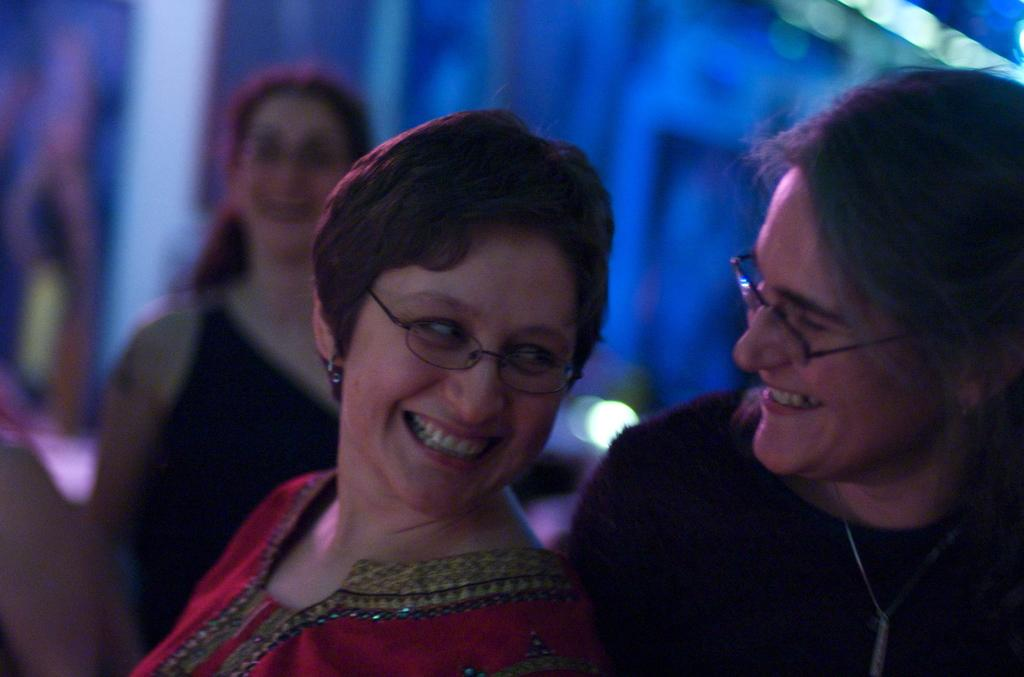How many persons are present in the image? There are persons in the image. Can you describe any specific features of the persons? Two of the persons are wearing specs. What is the lady wearing in the image? The lady is wearing a red dress. How would you describe the background of the image? The background of the image is blurred. How many fingers does the wave have in the image? There is no wave or fingers present in the image. What force is being exerted by the persons in the image? The provided facts do not mention any force being exerted by the persons in the image. 